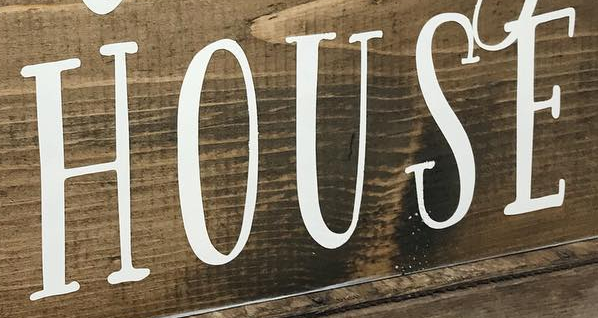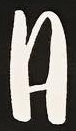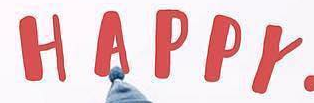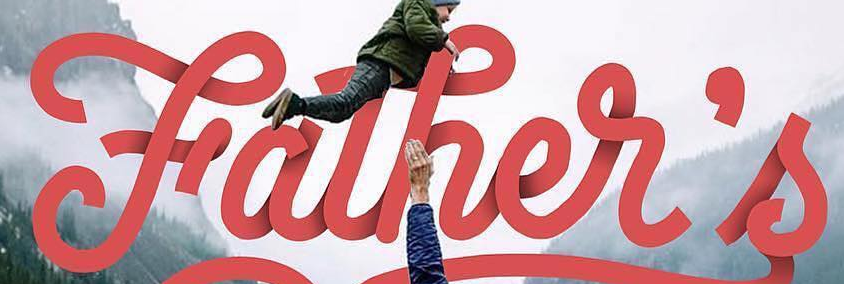What words can you see in these images in sequence, separated by a semicolon? HOUSE; A; HAPPY; Father's 